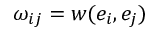<formula> <loc_0><loc_0><loc_500><loc_500>\omega _ { i j } = w ( e _ { i } , e _ { j } )</formula> 